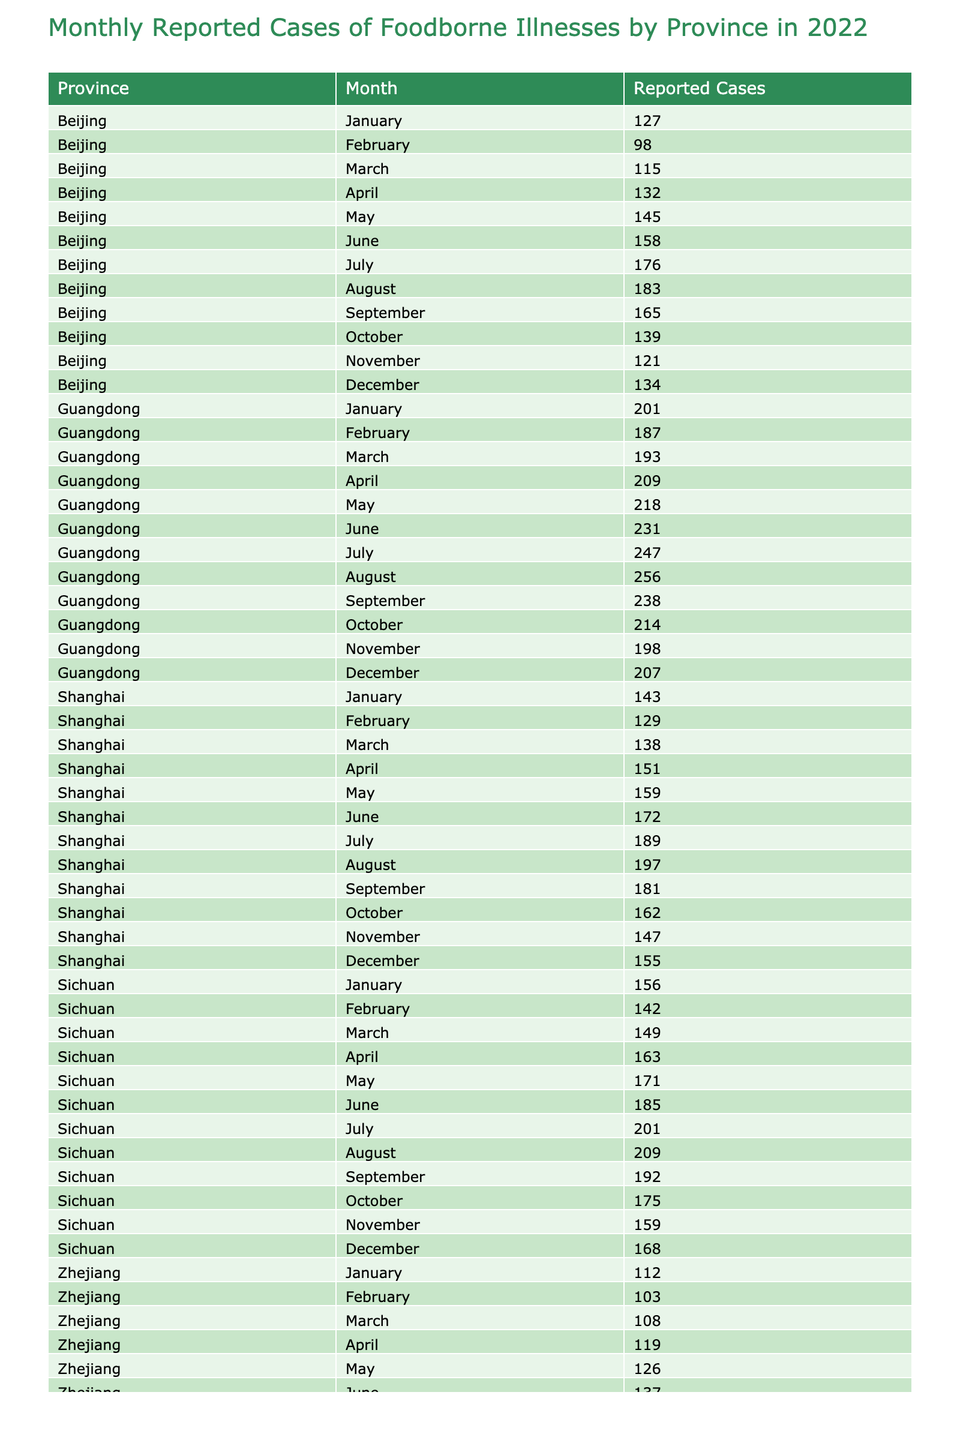what is the total number of reported cases in Guangdong for the entire year? To find the total reported cases in Guangdong, we need to sum the values for each month: 201 (Jan) + 187 (Feb) + 193 (Mar) + 209 (Apr) + 218 (May) + 231 (Jun) + 247 (Jul) + 256 (Aug) + 238 (Sep) + 214 (Oct) + 198 (Nov) + 207 (Dec) = 2,642
Answer: 2642 which province reported the most cases in June? In June, the reported cases are: Beijing 158, Shanghai 172, Guangdong 231, Sichuan 185, Zhejiang 137. Guangdong has the highest at 231.
Answer: Guangdong how many months did Beijing report over 150 cases? The values for Beijing are: 127 (Jan), 98 (Feb), 115 (Mar), 132 (Apr), 145 (May), 158 (Jun), 176 (Jul), 183 (Aug), 165 (Sep), 139 (Oct), 121 (Nov), 134 (Dec). The months with over 150 cases are June (158), July (176), and August (183). That makes it 3 months.
Answer: 3 did any province report less than 100 cases in any month? Reviewing the table, Beijing in February reported 98 cases and no other province reported less than 100 cases in any month. Therefore, yes, there was a reported count below 100.
Answer: Yes what is the average number of reported cases for Sichuan over the months of June, July, and August? The reported cases for Sichuan in those months are: 185 (Jun), 201 (Jul), and 209 (Aug). The average is calculated by summing these values: 185 + 201 + 209 = 595, then dividing by 3 gives us 595/3 = 198.33, rounded to 198.
Answer: 198 which month had the highest overall reported cases across all provinces? We need to sum the reported cases for each month: January (739), February (699), March (793), April (823), May (895), June (978), July (974), August (986), September (913), October (839), November (743), December (688). The highest is August with 986 cases.
Answer: August how does the number of reported cases in Shanghai compare to that in Zhejiang in October? In October, Shanghai reported 162 cases and Zhejiang reported 129 cases. Comparing these, Shanghai had 33 more cases than Zhejiang.
Answer: Shanghai had 33 more cases how many more cases did Guangdong report than Sichuan in July? In July, Guangdong reported 247 cases and Sichuan reported 201 cases. The difference is 247 - 201 = 46.
Answer: 46 did any province report consistently increasing cases from January to December? Looking at the reported cases across the months for each province, Guangdong shows a pattern of increasing cases every month from January (201) to August (256) before declining. No province showed consistent increases without decline.
Answer: No 